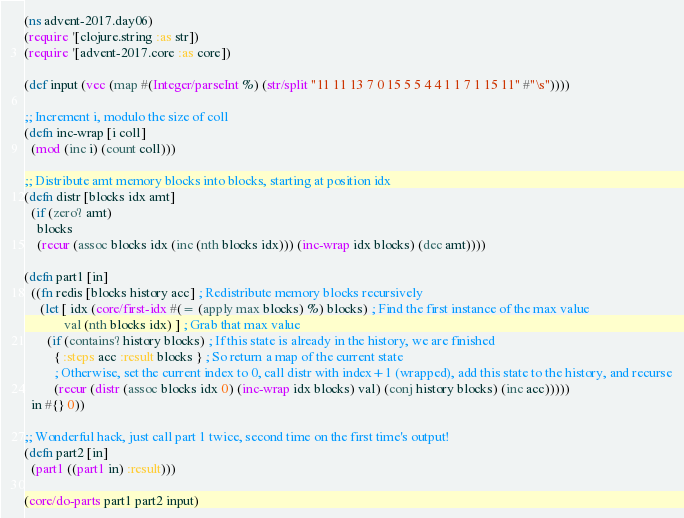Convert code to text. <code><loc_0><loc_0><loc_500><loc_500><_Clojure_>(ns advent-2017.day06)
(require '[clojure.string :as str])
(require '[advent-2017.core :as core])

(def input (vec (map #(Integer/parseInt %) (str/split "11 11 13 7 0 15 5 5 4 4 1 1 7 1 15 11" #"\s"))))

;; Increment i, modulo the size of coll
(defn inc-wrap [i coll] 
  (mod (inc i) (count coll)))

;; Distribute amt memory blocks into blocks, starting at position idx
(defn distr [blocks idx amt]
  (if (zero? amt)
    blocks
    (recur (assoc blocks idx (inc (nth blocks idx))) (inc-wrap idx blocks) (dec amt))))

(defn part1 [in]
  ((fn redis [blocks history acc] ; Redistribute memory blocks recursively
     (let [ idx (core/first-idx #(= (apply max blocks) %) blocks) ; Find the first instance of the max value
            val (nth blocks idx) ] ; Grab that max value
       (if (contains? history blocks) ; If this state is already in the history, we are finished
         { :steps acc :result blocks } ; So return a map of the current state
         ; Otherwise, set the current index to 0, call distr with index+1 (wrapped), add this state to the history, and recurse
         (recur (distr (assoc blocks idx 0) (inc-wrap idx blocks) val) (conj history blocks) (inc acc)))))
  in #{} 0))

;; Wonderful hack, just call part 1 twice, second time on the first time's output!
(defn part2 [in]
  (part1 ((part1 in) :result)))

(core/do-parts part1 part2 input)</code> 